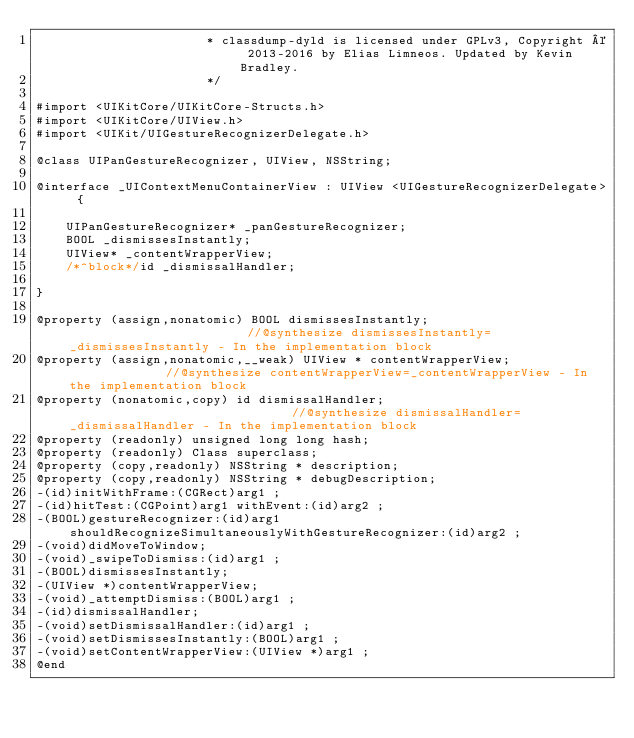<code> <loc_0><loc_0><loc_500><loc_500><_C_>                       * classdump-dyld is licensed under GPLv3, Copyright © 2013-2016 by Elias Limneos. Updated by Kevin Bradley.
                       */

#import <UIKitCore/UIKitCore-Structs.h>
#import <UIKitCore/UIView.h>
#import <UIKit/UIGestureRecognizerDelegate.h>

@class UIPanGestureRecognizer, UIView, NSString;

@interface _UIContextMenuContainerView : UIView <UIGestureRecognizerDelegate> {

	UIPanGestureRecognizer* _panGestureRecognizer;
	BOOL _dismissesInstantly;
	UIView* _contentWrapperView;
	/*^block*/id _dismissalHandler;

}

@property (assign,nonatomic) BOOL dismissesInstantly;                         //@synthesize dismissesInstantly=_dismissesInstantly - In the implementation block
@property (assign,nonatomic,__weak) UIView * contentWrapperView;              //@synthesize contentWrapperView=_contentWrapperView - In the implementation block
@property (nonatomic,copy) id dismissalHandler;                               //@synthesize dismissalHandler=_dismissalHandler - In the implementation block
@property (readonly) unsigned long long hash; 
@property (readonly) Class superclass; 
@property (copy,readonly) NSString * description; 
@property (copy,readonly) NSString * debugDescription; 
-(id)initWithFrame:(CGRect)arg1 ;
-(id)hitTest:(CGPoint)arg1 withEvent:(id)arg2 ;
-(BOOL)gestureRecognizer:(id)arg1 shouldRecognizeSimultaneouslyWithGestureRecognizer:(id)arg2 ;
-(void)didMoveToWindow;
-(void)_swipeToDismiss:(id)arg1 ;
-(BOOL)dismissesInstantly;
-(UIView *)contentWrapperView;
-(void)_attemptDismiss:(BOOL)arg1 ;
-(id)dismissalHandler;
-(void)setDismissalHandler:(id)arg1 ;
-(void)setDismissesInstantly:(BOOL)arg1 ;
-(void)setContentWrapperView:(UIView *)arg1 ;
@end

</code> 